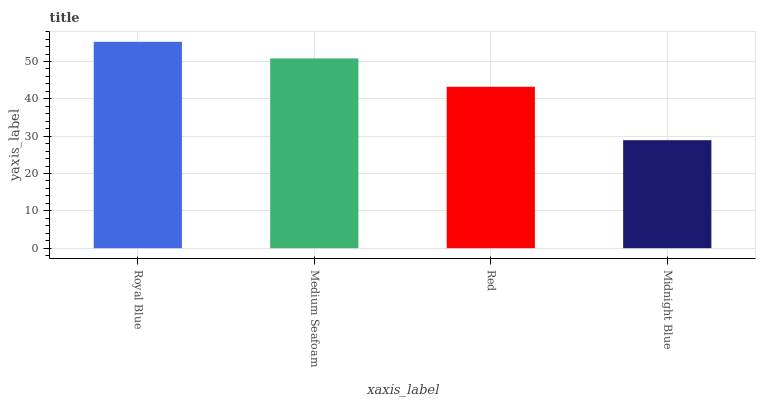Is Midnight Blue the minimum?
Answer yes or no. Yes. Is Royal Blue the maximum?
Answer yes or no. Yes. Is Medium Seafoam the minimum?
Answer yes or no. No. Is Medium Seafoam the maximum?
Answer yes or no. No. Is Royal Blue greater than Medium Seafoam?
Answer yes or no. Yes. Is Medium Seafoam less than Royal Blue?
Answer yes or no. Yes. Is Medium Seafoam greater than Royal Blue?
Answer yes or no. No. Is Royal Blue less than Medium Seafoam?
Answer yes or no. No. Is Medium Seafoam the high median?
Answer yes or no. Yes. Is Red the low median?
Answer yes or no. Yes. Is Royal Blue the high median?
Answer yes or no. No. Is Medium Seafoam the low median?
Answer yes or no. No. 